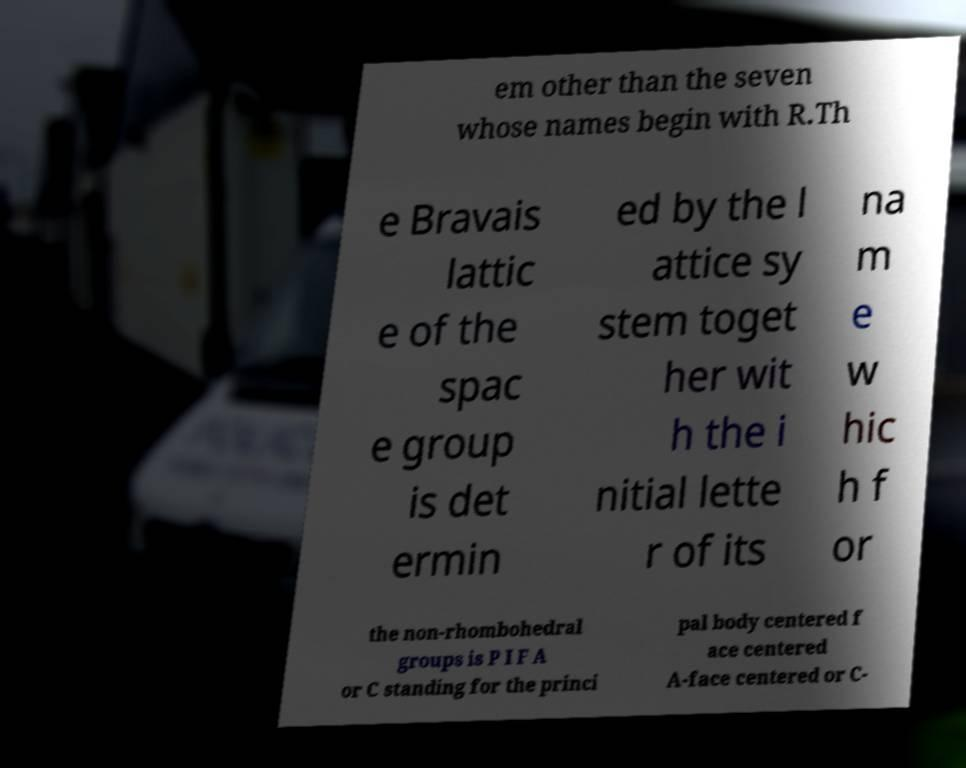Could you assist in decoding the text presented in this image and type it out clearly? em other than the seven whose names begin with R.Th e Bravais lattic e of the spac e group is det ermin ed by the l attice sy stem toget her wit h the i nitial lette r of its na m e w hic h f or the non-rhombohedral groups is P I F A or C standing for the princi pal body centered f ace centered A-face centered or C- 